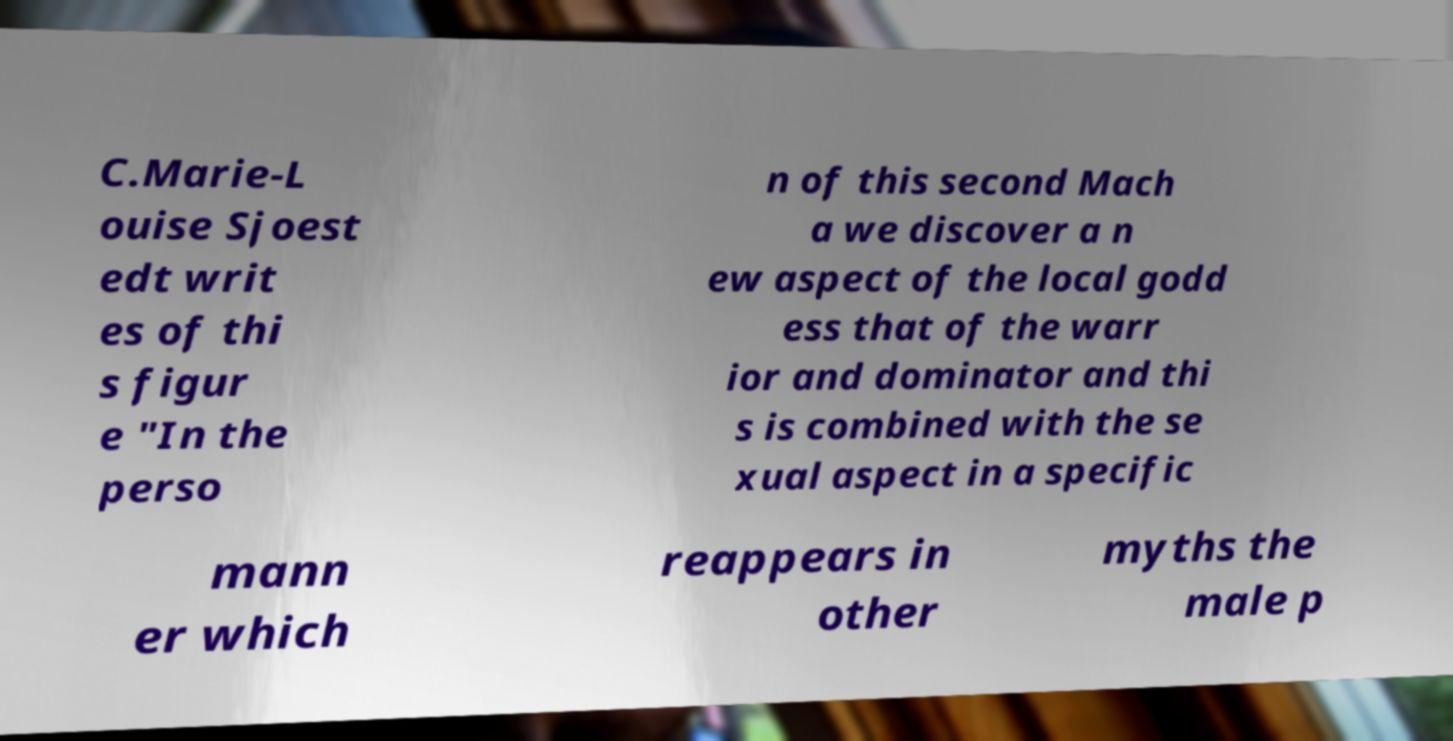Could you extract and type out the text from this image? C.Marie-L ouise Sjoest edt writ es of thi s figur e "In the perso n of this second Mach a we discover a n ew aspect of the local godd ess that of the warr ior and dominator and thi s is combined with the se xual aspect in a specific mann er which reappears in other myths the male p 